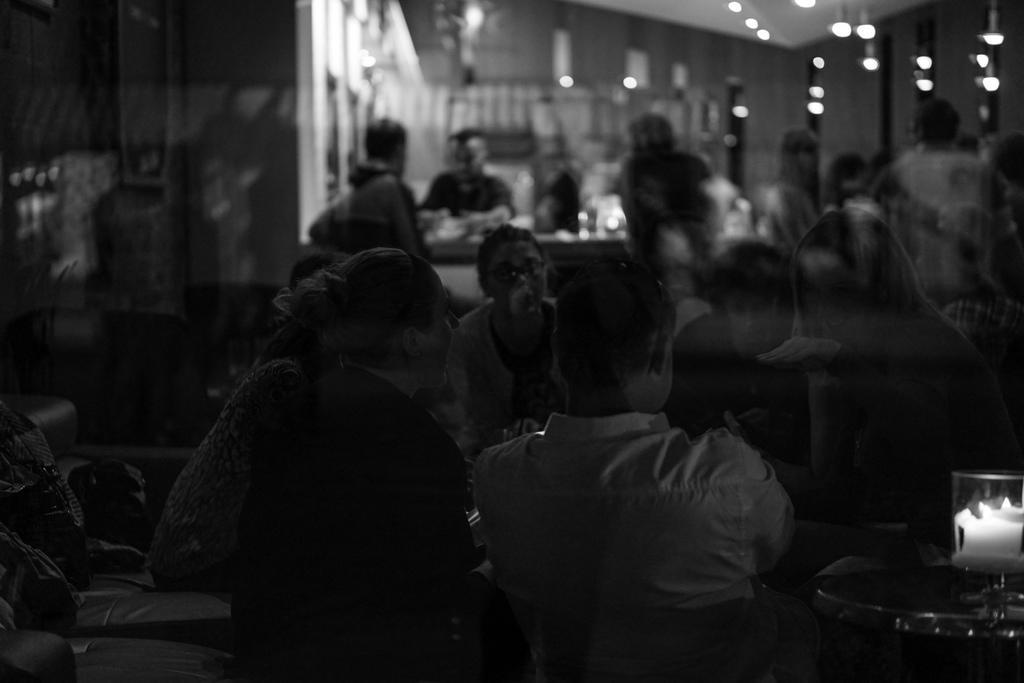Describe this image in one or two sentences. This is a black and white image, in this image there are a group of people who are sitting on chairs and also there are some tables. On the right side there is one stool and some objects, and in the background there are some lights and wall and in the foreground there might be a window. 